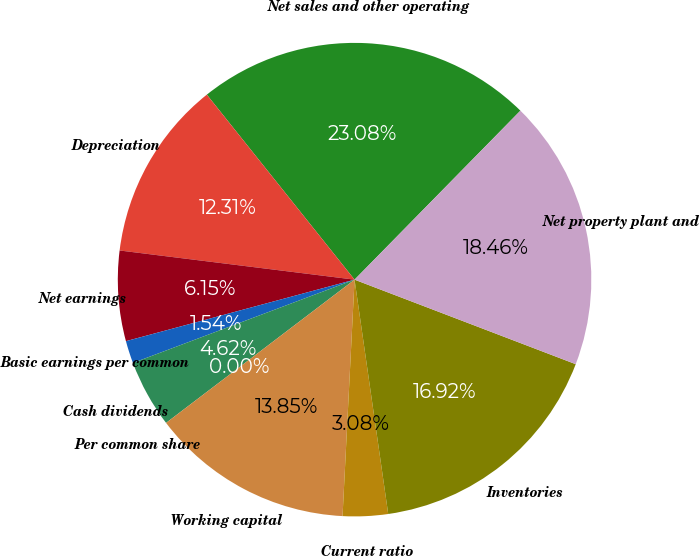<chart> <loc_0><loc_0><loc_500><loc_500><pie_chart><fcel>Net sales and other operating<fcel>Depreciation<fcel>Net earnings<fcel>Basic earnings per common<fcel>Cash dividends<fcel>Per common share<fcel>Working capital<fcel>Current ratio<fcel>Inventories<fcel>Net property plant and<nl><fcel>23.08%<fcel>12.31%<fcel>6.15%<fcel>1.54%<fcel>4.62%<fcel>0.0%<fcel>13.85%<fcel>3.08%<fcel>16.92%<fcel>18.46%<nl></chart> 